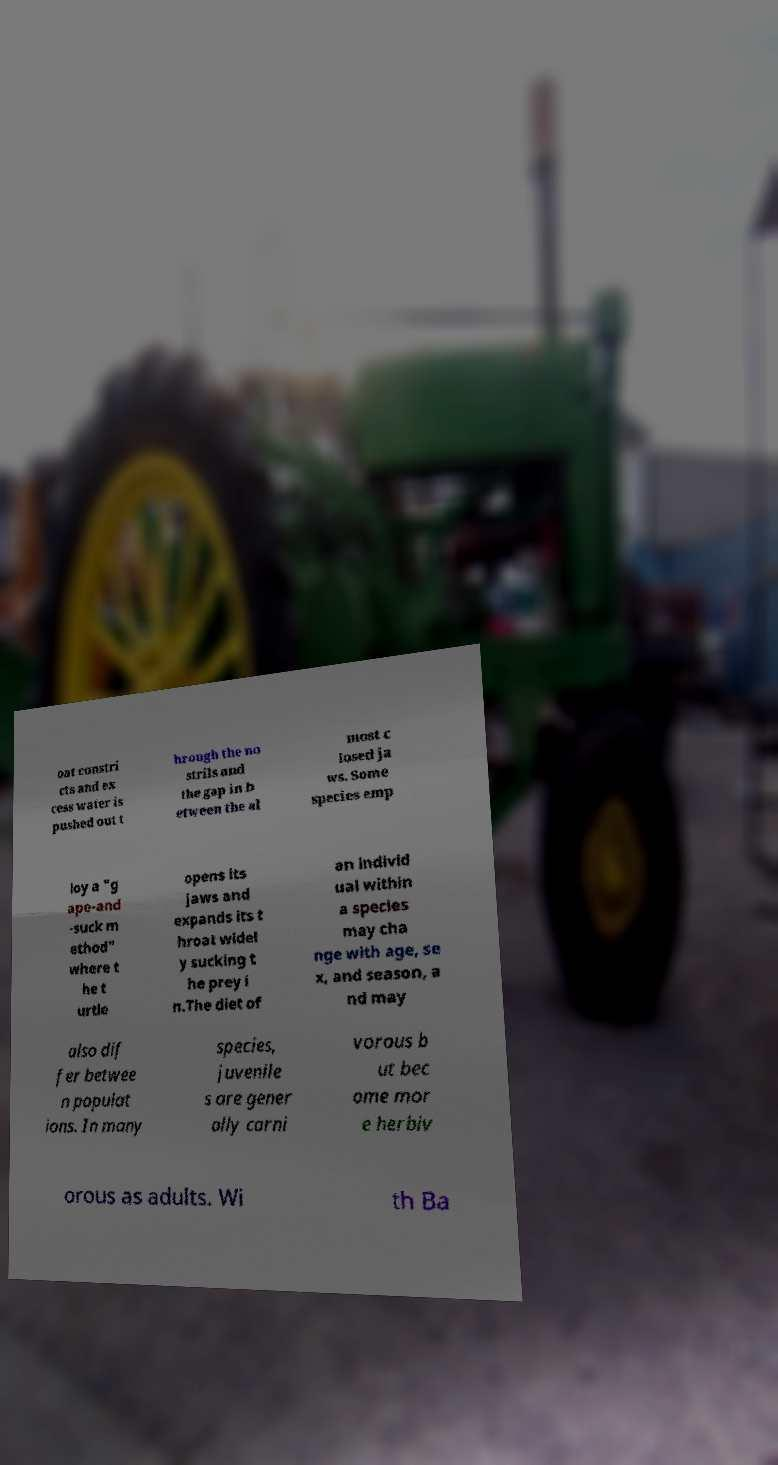For documentation purposes, I need the text within this image transcribed. Could you provide that? oat constri cts and ex cess water is pushed out t hrough the no strils and the gap in b etween the al most c losed ja ws. Some species emp loy a "g ape-and -suck m ethod" where t he t urtle opens its jaws and expands its t hroat widel y sucking t he prey i n.The diet of an individ ual within a species may cha nge with age, se x, and season, a nd may also dif fer betwee n populat ions. In many species, juvenile s are gener ally carni vorous b ut bec ome mor e herbiv orous as adults. Wi th Ba 